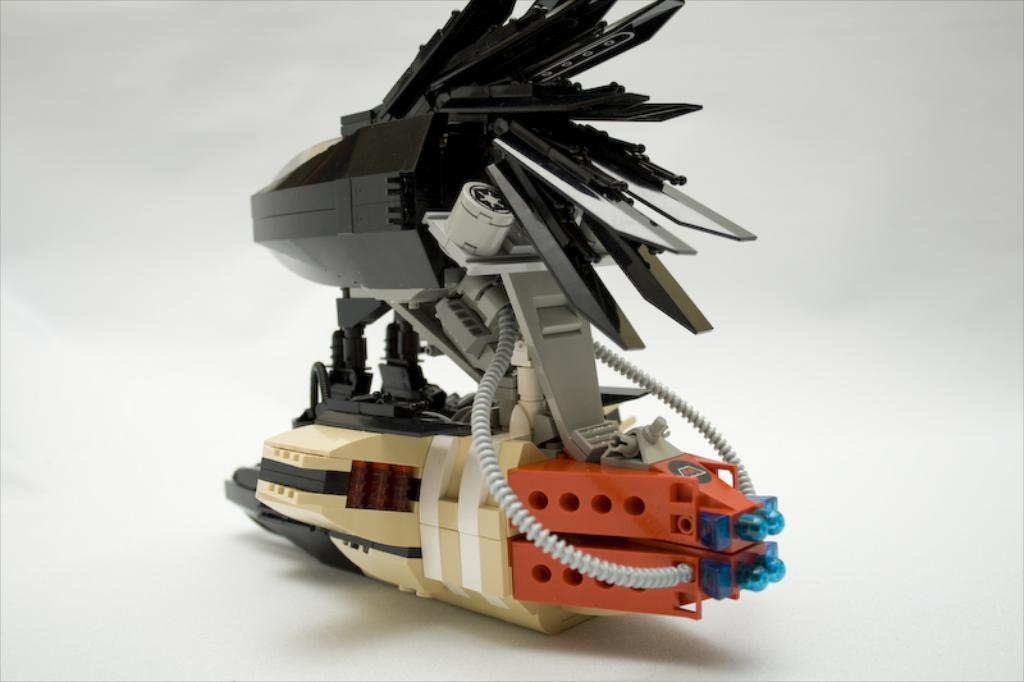What is the main object in the image? There is a device in the image. What are the color tubes on the device? The color tubes on the device are gray. What type of lights are present on the device? The device has blue color lights. On what surface is the device placed? The device is on a surface. What is the color of the background in the image? The background of the image is white in color. Where is the father sitting in the image? There is no father present in the image; it only features a device with gray color tubes and blue color lights. What type of level is being used in the image? There is no level present in the image; it only features a device with gray color tubes and blue color lights. 